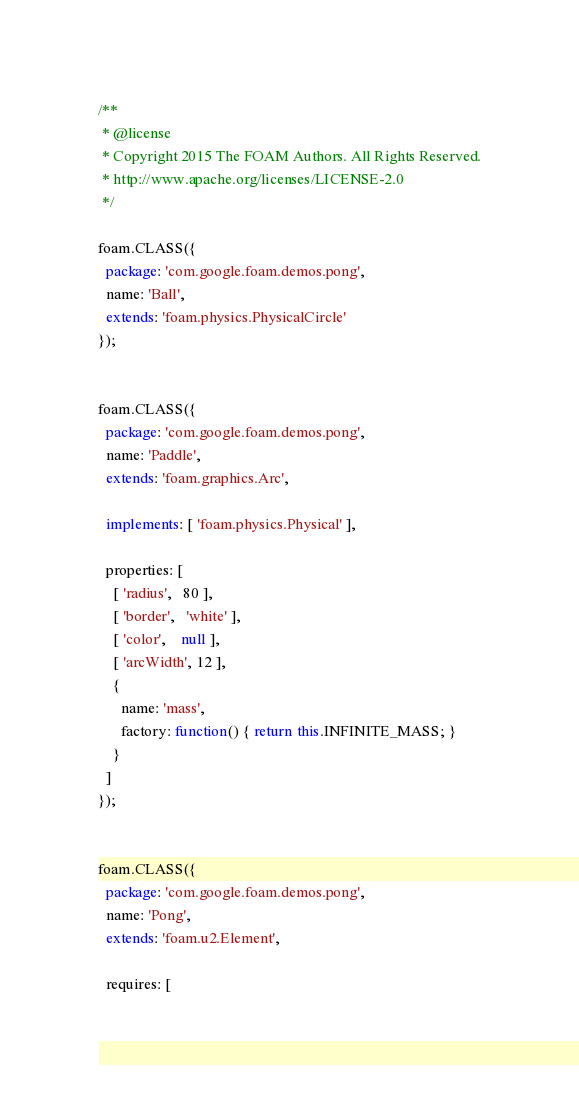<code> <loc_0><loc_0><loc_500><loc_500><_JavaScript_>/**
 * @license
 * Copyright 2015 The FOAM Authors. All Rights Reserved.
 * http://www.apache.org/licenses/LICENSE-2.0
 */

foam.CLASS({
  package: 'com.google.foam.demos.pong',
  name: 'Ball',
  extends: 'foam.physics.PhysicalCircle'
});


foam.CLASS({
  package: 'com.google.foam.demos.pong',
  name: 'Paddle',
  extends: 'foam.graphics.Arc',

  implements: [ 'foam.physics.Physical' ],

  properties: [
    [ 'radius',   80 ],
    [ 'border',   'white' ],
    [ 'color',    null ],
    [ 'arcWidth', 12 ],
    {
      name: 'mass',
      factory: function() { return this.INFINITE_MASS; }
    }
  ]
});


foam.CLASS({
  package: 'com.google.foam.demos.pong',
  name: 'Pong',
  extends: 'foam.u2.Element',

  requires: [</code> 